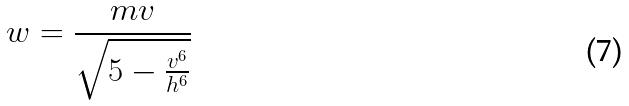Convert formula to latex. <formula><loc_0><loc_0><loc_500><loc_500>w = \frac { m v } { \sqrt { 5 - \frac { v ^ { 6 } } { h ^ { 6 } } } }</formula> 